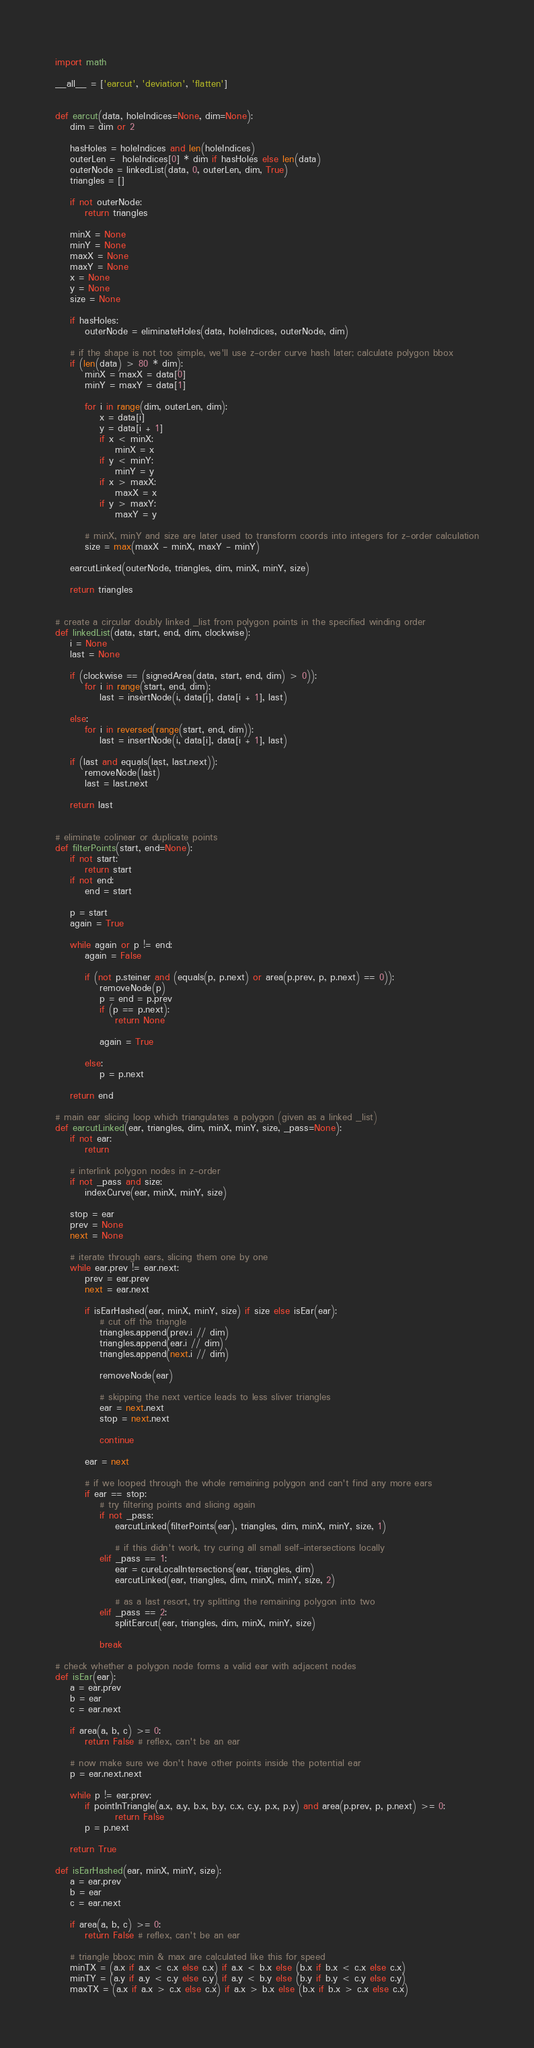Convert code to text. <code><loc_0><loc_0><loc_500><loc_500><_Python_>import math

__all__ = ['earcut', 'deviation', 'flatten']


def earcut(data, holeIndices=None, dim=None):
    dim = dim or 2

    hasHoles = holeIndices and len(holeIndices)
    outerLen =  holeIndices[0] * dim if hasHoles else len(data)
    outerNode = linkedList(data, 0, outerLen, dim, True)
    triangles = []

    if not outerNode:
        return triangles

    minX = None
    minY = None
    maxX = None
    maxY = None
    x = None
    y = None
    size = None

    if hasHoles:
        outerNode = eliminateHoles(data, holeIndices, outerNode, dim)

    # if the shape is not too simple, we'll use z-order curve hash later; calculate polygon bbox
    if (len(data) > 80 * dim):
        minX = maxX = data[0]
        minY = maxY = data[1]

        for i in range(dim, outerLen, dim):
            x = data[i]
            y = data[i + 1]
            if x < minX:
                minX = x
            if y < minY:
                minY = y
            if x > maxX:
                maxX = x
            if y > maxY:
                maxY = y

        # minX, minY and size are later used to transform coords into integers for z-order calculation
        size = max(maxX - minX, maxY - minY)

    earcutLinked(outerNode, triangles, dim, minX, minY, size)

    return triangles


# create a circular doubly linked _list from polygon points in the specified winding order
def linkedList(data, start, end, dim, clockwise):
    i = None
    last = None

    if (clockwise == (signedArea(data, start, end, dim) > 0)):
        for i in range(start, end, dim):
            last = insertNode(i, data[i], data[i + 1], last)

    else:
        for i in reversed(range(start, end, dim)):
            last = insertNode(i, data[i], data[i + 1], last)

    if (last and equals(last, last.next)):
        removeNode(last)
        last = last.next

    return last


# eliminate colinear or duplicate points
def filterPoints(start, end=None):
    if not start:
        return start
    if not end:
        end = start

    p = start
    again = True

    while again or p != end:
        again = False

        if (not p.steiner and (equals(p, p.next) or area(p.prev, p, p.next) == 0)):
            removeNode(p)
            p = end = p.prev
            if (p == p.next):
                return None

            again = True

        else:
            p = p.next

    return end

# main ear slicing loop which triangulates a polygon (given as a linked _list)
def earcutLinked(ear, triangles, dim, minX, minY, size, _pass=None):
    if not ear:
        return

    # interlink polygon nodes in z-order
    if not _pass and size:
        indexCurve(ear, minX, minY, size)

    stop = ear
    prev = None
    next = None

    # iterate through ears, slicing them one by one
    while ear.prev != ear.next:
        prev = ear.prev
        next = ear.next

        if isEarHashed(ear, minX, minY, size) if size else isEar(ear):
            # cut off the triangle
            triangles.append(prev.i // dim)
            triangles.append(ear.i // dim)
            triangles.append(next.i // dim)

            removeNode(ear)

            # skipping the next vertice leads to less sliver triangles
            ear = next.next
            stop = next.next

            continue

        ear = next

        # if we looped through the whole remaining polygon and can't find any more ears
        if ear == stop:
            # try filtering points and slicing again
            if not _pass:
                earcutLinked(filterPoints(ear), triangles, dim, minX, minY, size, 1)

                # if this didn't work, try curing all small self-intersections locally
            elif _pass == 1:
                ear = cureLocalIntersections(ear, triangles, dim)
                earcutLinked(ear, triangles, dim, minX, minY, size, 2)

                # as a last resort, try splitting the remaining polygon into two
            elif _pass == 2:
                splitEarcut(ear, triangles, dim, minX, minY, size)

            break

# check whether a polygon node forms a valid ear with adjacent nodes
def isEar(ear):
    a = ear.prev
    b = ear
    c = ear.next

    if area(a, b, c) >= 0:
        return False # reflex, can't be an ear

    # now make sure we don't have other points inside the potential ear
    p = ear.next.next

    while p != ear.prev:
        if pointInTriangle(a.x, a.y, b.x, b.y, c.x, c.y, p.x, p.y) and area(p.prev, p, p.next) >= 0:
                return False
        p = p.next

    return True

def isEarHashed(ear, minX, minY, size):
    a = ear.prev
    b = ear
    c = ear.next

    if area(a, b, c) >= 0:
        return False # reflex, can't be an ear

    # triangle bbox; min & max are calculated like this for speed
    minTX = (a.x if a.x < c.x else c.x) if a.x < b.x else (b.x if b.x < c.x else c.x)
    minTY = (a.y if a.y < c.y else c.y) if a.y < b.y else (b.y if b.y < c.y else c.y)
    maxTX = (a.x if a.x > c.x else c.x) if a.x > b.x else (b.x if b.x > c.x else c.x)</code> 